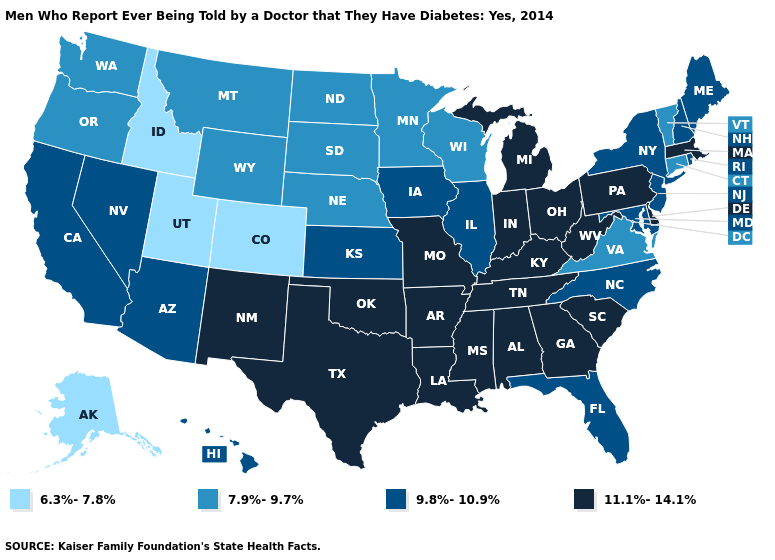What is the value of Texas?
Be succinct. 11.1%-14.1%. Among the states that border West Virginia , which have the highest value?
Be succinct. Kentucky, Ohio, Pennsylvania. Name the states that have a value in the range 11.1%-14.1%?
Keep it brief. Alabama, Arkansas, Delaware, Georgia, Indiana, Kentucky, Louisiana, Massachusetts, Michigan, Mississippi, Missouri, New Mexico, Ohio, Oklahoma, Pennsylvania, South Carolina, Tennessee, Texas, West Virginia. What is the value of Maryland?
Answer briefly. 9.8%-10.9%. Among the states that border Delaware , which have the highest value?
Quick response, please. Pennsylvania. What is the lowest value in the USA?
Concise answer only. 6.3%-7.8%. What is the value of Louisiana?
Write a very short answer. 11.1%-14.1%. What is the value of New York?
Write a very short answer. 9.8%-10.9%. What is the lowest value in states that border Nevada?
Quick response, please. 6.3%-7.8%. What is the value of Nebraska?
Answer briefly. 7.9%-9.7%. What is the lowest value in the MidWest?
Quick response, please. 7.9%-9.7%. Among the states that border North Carolina , which have the lowest value?
Quick response, please. Virginia. Does the first symbol in the legend represent the smallest category?
Answer briefly. Yes. What is the value of Oklahoma?
Write a very short answer. 11.1%-14.1%. What is the lowest value in the West?
Answer briefly. 6.3%-7.8%. 